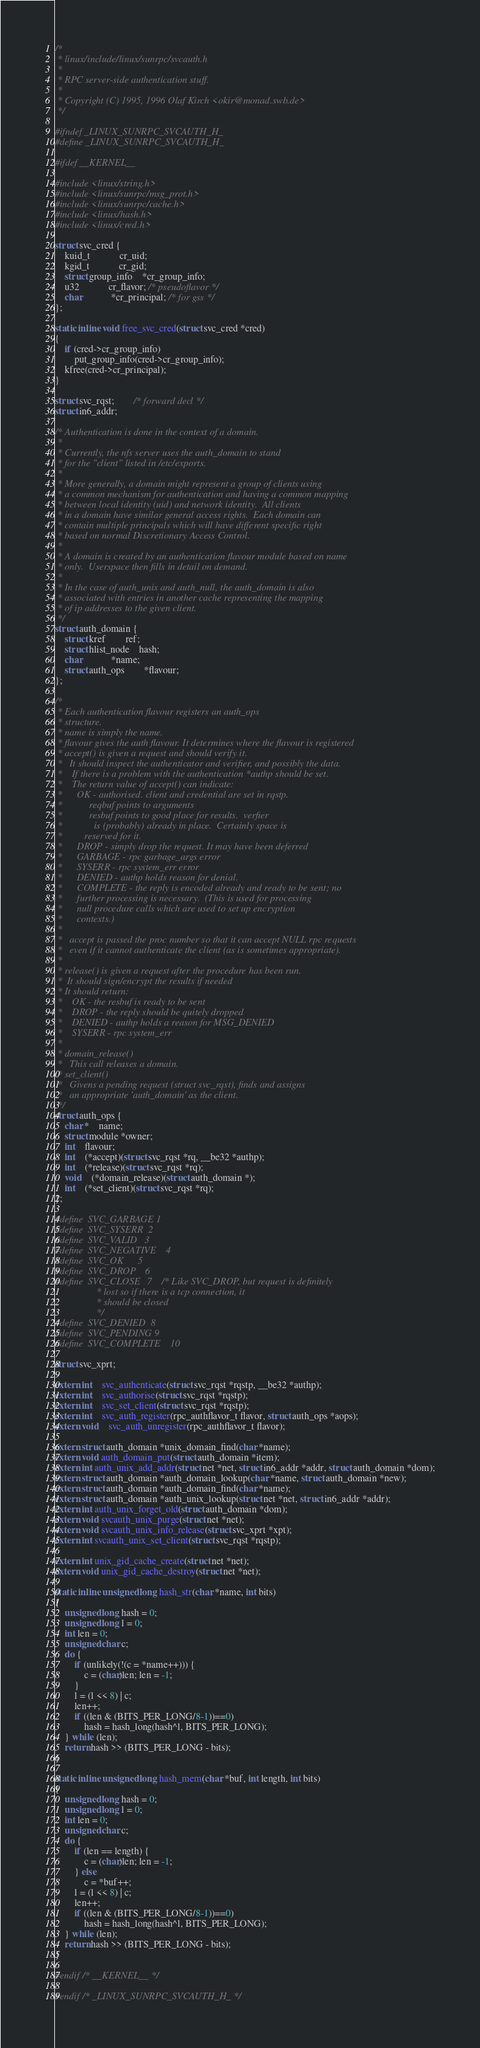Convert code to text. <code><loc_0><loc_0><loc_500><loc_500><_C_>/*
 * linux/include/linux/sunrpc/svcauth.h
 *
 * RPC server-side authentication stuff.
 *
 * Copyright (C) 1995, 1996 Olaf Kirch <okir@monad.swb.de>
 */

#ifndef _LINUX_SUNRPC_SVCAUTH_H_
#define _LINUX_SUNRPC_SVCAUTH_H_

#ifdef __KERNEL__

#include <linux/string.h>
#include <linux/sunrpc/msg_prot.h>
#include <linux/sunrpc/cache.h>
#include <linux/hash.h>
#include <linux/cred.h>

struct svc_cred {
	kuid_t			cr_uid;
	kgid_t			cr_gid;
	struct group_info	*cr_group_info;
	u32			cr_flavor; /* pseudoflavor */
	char			*cr_principal; /* for gss */
};

static inline void free_svc_cred(struct svc_cred *cred)
{
	if (cred->cr_group_info)
		put_group_info(cred->cr_group_info);
	kfree(cred->cr_principal);
}

struct svc_rqst;		/* forward decl */
struct in6_addr;

/* Authentication is done in the context of a domain.
 *
 * Currently, the nfs server uses the auth_domain to stand
 * for the "client" listed in /etc/exports.
 *
 * More generally, a domain might represent a group of clients using
 * a common mechanism for authentication and having a common mapping
 * between local identity (uid) and network identity.  All clients
 * in a domain have similar general access rights.  Each domain can
 * contain multiple principals which will have different specific right
 * based on normal Discretionary Access Control.
 *
 * A domain is created by an authentication flavour module based on name
 * only.  Userspace then fills in detail on demand.
 *
 * In the case of auth_unix and auth_null, the auth_domain is also
 * associated with entries in another cache representing the mapping
 * of ip addresses to the given client.
 */
struct auth_domain {
	struct kref		ref;
	struct hlist_node	hash;
	char			*name;
	struct auth_ops		*flavour;
};

/*
 * Each authentication flavour registers an auth_ops
 * structure.
 * name is simply the name.
 * flavour gives the auth flavour. It determines where the flavour is registered
 * accept() is given a request and should verify it.
 *   It should inspect the authenticator and verifier, and possibly the data.
 *    If there is a problem with the authentication *authp should be set.
 *    The return value of accept() can indicate:
 *      OK - authorised. client and credential are set in rqstp.
 *           reqbuf points to arguments
 *           resbuf points to good place for results.  verfier
 *             is (probably) already in place.  Certainly space is
 *	       reserved for it.
 *      DROP - simply drop the request. It may have been deferred
 *      GARBAGE - rpc garbage_args error
 *      SYSERR - rpc system_err error
 *      DENIED - authp holds reason for denial.
 *      COMPLETE - the reply is encoded already and ready to be sent; no
 *		further processing is necessary.  (This is used for processing
 *		null procedure calls which are used to set up encryption
 *		contexts.)
 *
 *   accept is passed the proc number so that it can accept NULL rpc requests
 *   even if it cannot authenticate the client (as is sometimes appropriate).
 *
 * release() is given a request after the procedure has been run.
 *  It should sign/encrypt the results if needed
 * It should return:
 *    OK - the resbuf is ready to be sent
 *    DROP - the reply should be quitely dropped
 *    DENIED - authp holds a reason for MSG_DENIED
 *    SYSERR - rpc system_err
 *
 * domain_release()
 *   This call releases a domain.
 * set_client()
 *   Givens a pending request (struct svc_rqst), finds and assigns
 *   an appropriate 'auth_domain' as the client.
 */
struct auth_ops {
	char *	name;
	struct module *owner;
	int	flavour;
	int	(*accept)(struct svc_rqst *rq, __be32 *authp);
	int	(*release)(struct svc_rqst *rq);
	void	(*domain_release)(struct auth_domain *);
	int	(*set_client)(struct svc_rqst *rq);
};

#define	SVC_GARBAGE	1
#define	SVC_SYSERR	2
#define	SVC_VALID	3
#define	SVC_NEGATIVE	4
#define	SVC_OK		5
#define	SVC_DROP	6
#define	SVC_CLOSE	7	/* Like SVC_DROP, but request is definitely
				 * lost so if there is a tcp connection, it
				 * should be closed
				 */
#define	SVC_DENIED	8
#define	SVC_PENDING	9
#define	SVC_COMPLETE	10

struct svc_xprt;

extern int	svc_authenticate(struct svc_rqst *rqstp, __be32 *authp);
extern int	svc_authorise(struct svc_rqst *rqstp);
extern int	svc_set_client(struct svc_rqst *rqstp);
extern int	svc_auth_register(rpc_authflavor_t flavor, struct auth_ops *aops);
extern void	svc_auth_unregister(rpc_authflavor_t flavor);

extern struct auth_domain *unix_domain_find(char *name);
extern void auth_domain_put(struct auth_domain *item);
extern int auth_unix_add_addr(struct net *net, struct in6_addr *addr, struct auth_domain *dom);
extern struct auth_domain *auth_domain_lookup(char *name, struct auth_domain *new);
extern struct auth_domain *auth_domain_find(char *name);
extern struct auth_domain *auth_unix_lookup(struct net *net, struct in6_addr *addr);
extern int auth_unix_forget_old(struct auth_domain *dom);
extern void svcauth_unix_purge(struct net *net);
extern void svcauth_unix_info_release(struct svc_xprt *xpt);
extern int svcauth_unix_set_client(struct svc_rqst *rqstp);

extern int unix_gid_cache_create(struct net *net);
extern void unix_gid_cache_destroy(struct net *net);

static inline unsigned long hash_str(char *name, int bits)
{
	unsigned long hash = 0;
	unsigned long l = 0;
	int len = 0;
	unsigned char c;
	do {
		if (unlikely(!(c = *name++))) {
			c = (char)len; len = -1;
		}
		l = (l << 8) | c;
		len++;
		if ((len & (BITS_PER_LONG/8-1))==0)
			hash = hash_long(hash^l, BITS_PER_LONG);
	} while (len);
	return hash >> (BITS_PER_LONG - bits);
}

static inline unsigned long hash_mem(char *buf, int length, int bits)
{
	unsigned long hash = 0;
	unsigned long l = 0;
	int len = 0;
	unsigned char c;
	do {
		if (len == length) {
			c = (char)len; len = -1;
		} else
			c = *buf++;
		l = (l << 8) | c;
		len++;
		if ((len & (BITS_PER_LONG/8-1))==0)
			hash = hash_long(hash^l, BITS_PER_LONG);
	} while (len);
	return hash >> (BITS_PER_LONG - bits);
}

#endif /* __KERNEL__ */

#endif /* _LINUX_SUNRPC_SVCAUTH_H_ */
</code> 